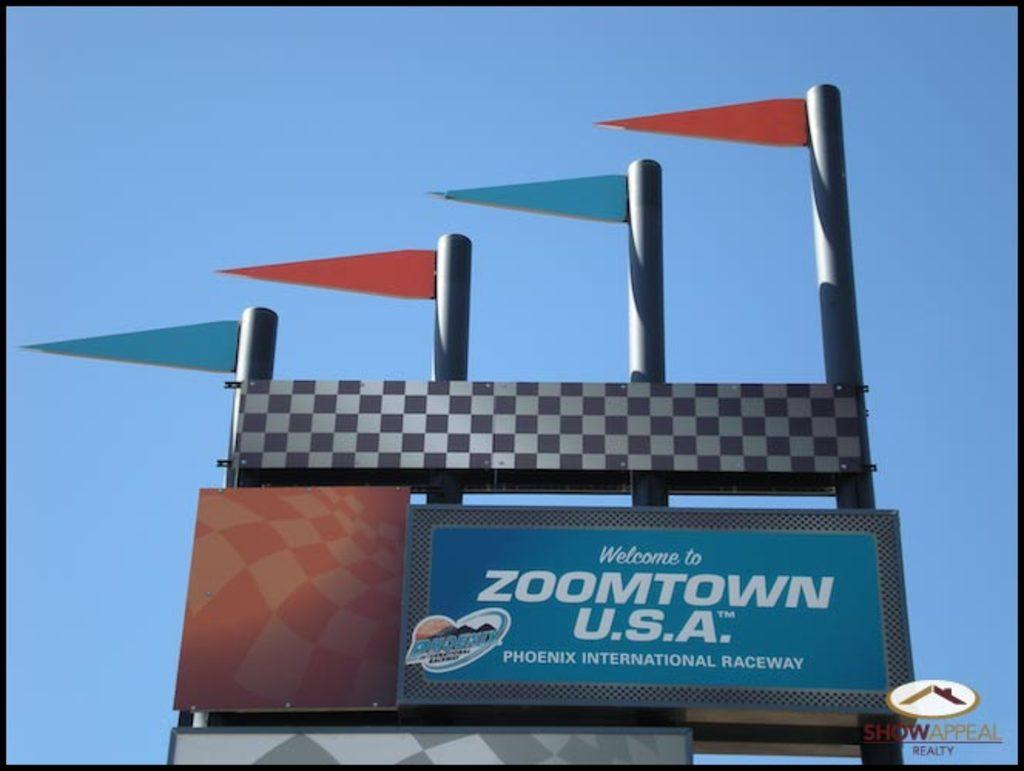<image>
Share a concise interpretation of the image provided. Zoomtown U.S.A. is what they call the Phoenix International Raceway. 